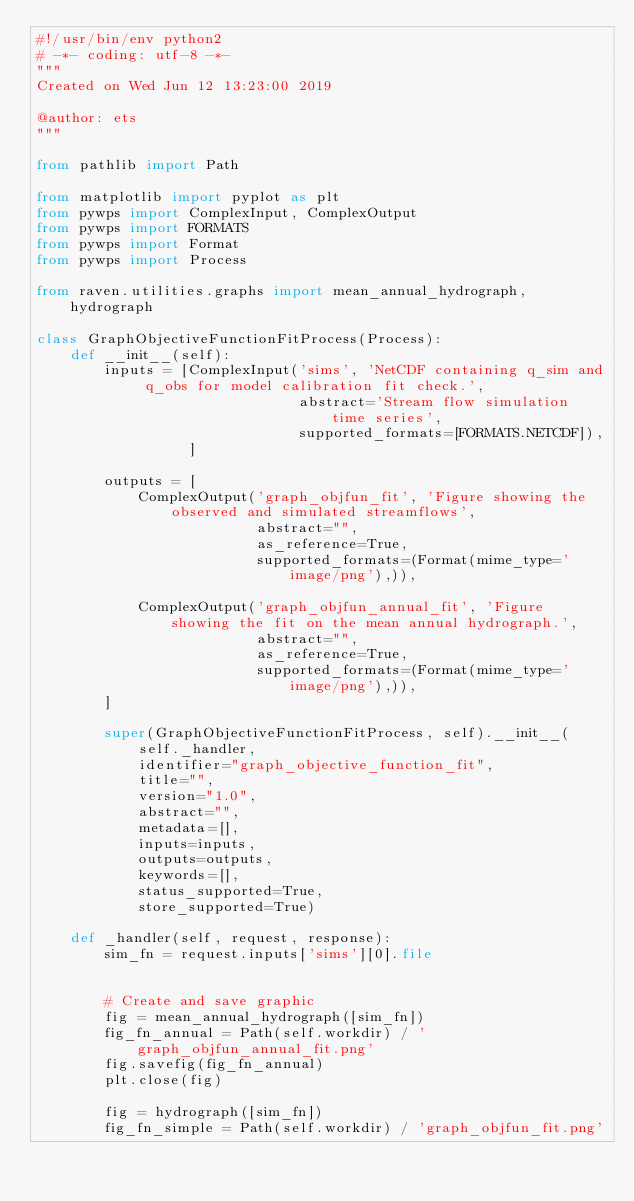Convert code to text. <code><loc_0><loc_0><loc_500><loc_500><_Python_>#!/usr/bin/env python2
# -*- coding: utf-8 -*-
"""
Created on Wed Jun 12 13:23:00 2019

@author: ets
"""

from pathlib import Path

from matplotlib import pyplot as plt
from pywps import ComplexInput, ComplexOutput
from pywps import FORMATS
from pywps import Format
from pywps import Process

from raven.utilities.graphs import mean_annual_hydrograph, hydrograph

class GraphObjectiveFunctionFitProcess(Process):
    def __init__(self):
        inputs = [ComplexInput('sims', 'NetCDF containing q_sim and q_obs for model calibration fit check.',
                               abstract='Stream flow simulation time series',
                               supported_formats=[FORMATS.NETCDF]),
                  ]

        outputs = [
            ComplexOutput('graph_objfun_fit', 'Figure showing the observed and simulated streamflows',
                          abstract="",
                          as_reference=True,
                          supported_formats=(Format(mime_type='image/png'),)),

            ComplexOutput('graph_objfun_annual_fit', 'Figure showing the fit on the mean annual hydrograph.',
                          abstract="",
                          as_reference=True,
                          supported_formats=(Format(mime_type='image/png'),)),
        ]

        super(GraphObjectiveFunctionFitProcess, self).__init__(
            self._handler,
            identifier="graph_objective_function_fit",
            title="",
            version="1.0",
            abstract="",
            metadata=[],
            inputs=inputs,
            outputs=outputs,
            keywords=[],
            status_supported=True,
            store_supported=True)

    def _handler(self, request, response):
        sim_fn = request.inputs['sims'][0].file
      
        
        # Create and save graphic
        fig = mean_annual_hydrograph([sim_fn])
        fig_fn_annual = Path(self.workdir) / 'graph_objfun_annual_fit.png'
        fig.savefig(fig_fn_annual)
        plt.close(fig)

        fig = hydrograph([sim_fn])
        fig_fn_simple = Path(self.workdir) / 'graph_objfun_fit.png'</code> 